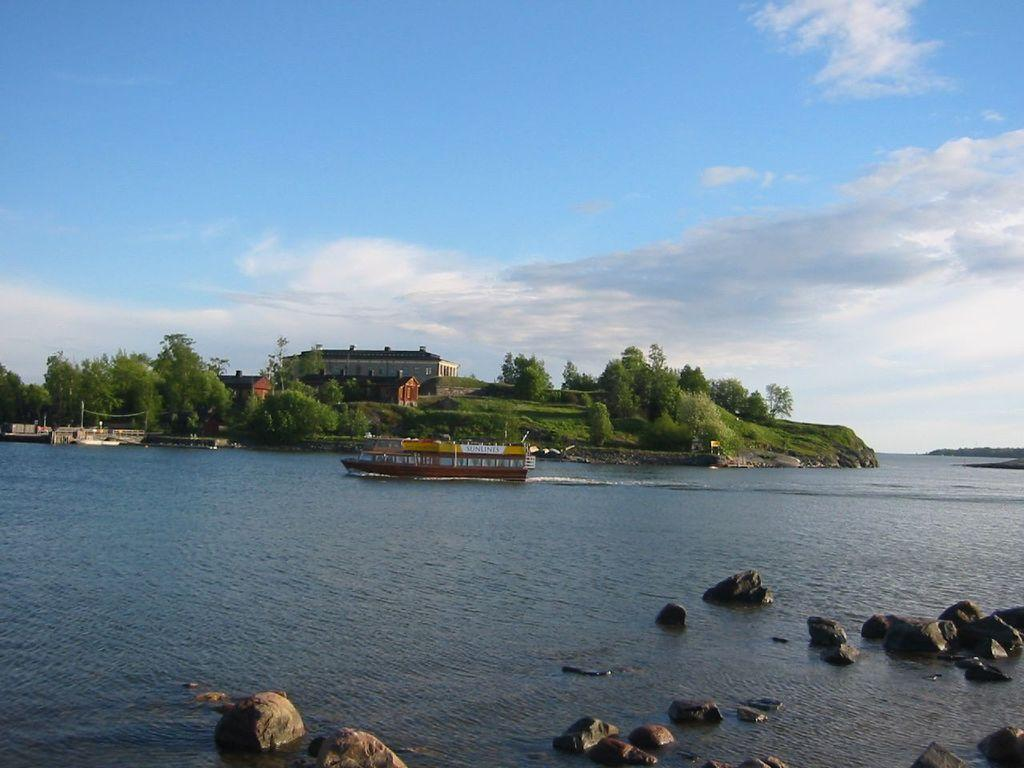What is the main subject of the image? The main subject of the image is a ship. Where is the ship located in the image? The ship is on the water in the image. What else can be seen in the water? There are rocks in the water. What structures are visible in the image? There are buildings visible in the image. What type of vegetation is present in the image? There are trees in the image. What is visible at the top of the image? The sky is visible at the top of the image, and clouds are present in the sky. How does the hen contribute to the riddle in the image? There is no hen or riddle present in the image. 